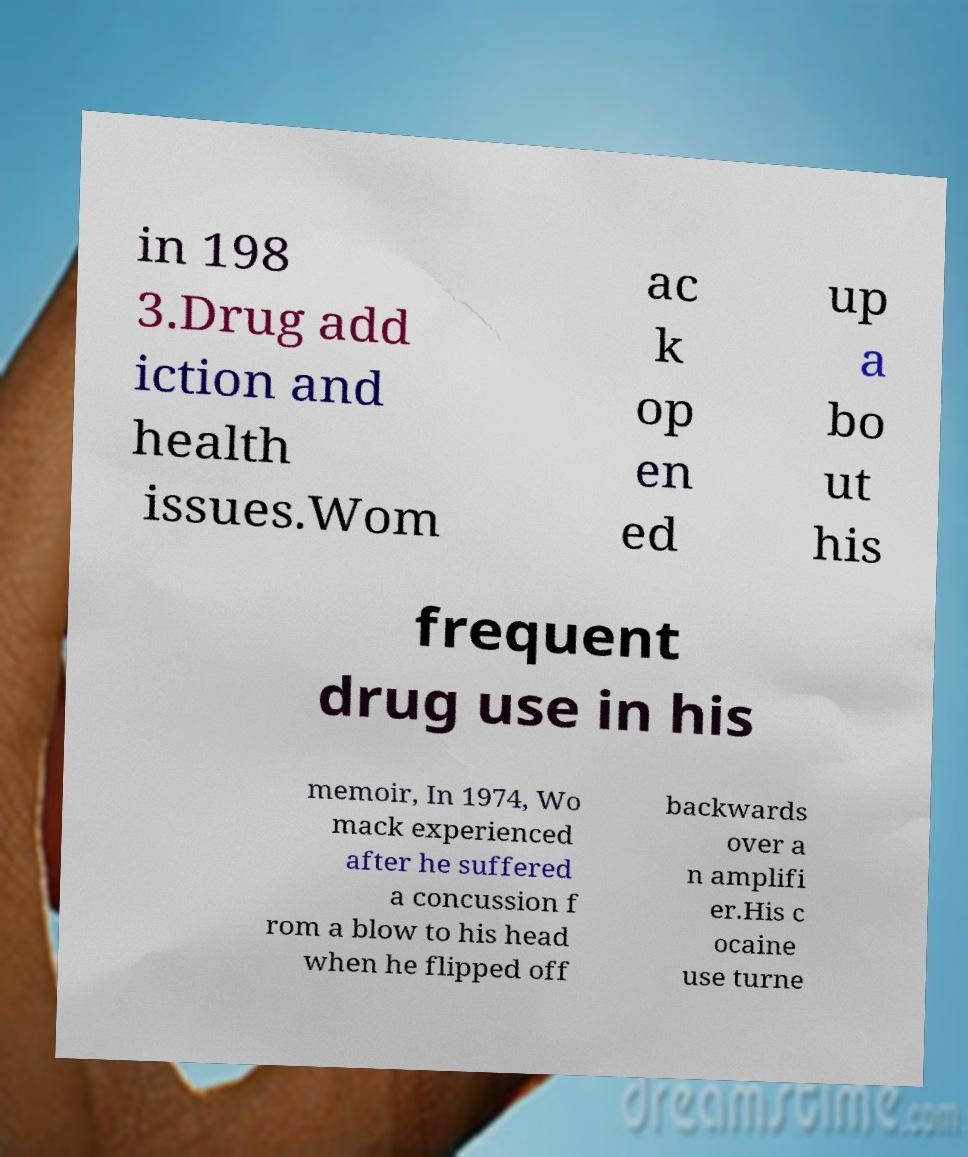Could you assist in decoding the text presented in this image and type it out clearly? in 198 3.Drug add iction and health issues.Wom ac k op en ed up a bo ut his frequent drug use in his memoir, In 1974, Wo mack experienced after he suffered a concussion f rom a blow to his head when he flipped off backwards over a n amplifi er.His c ocaine use turne 